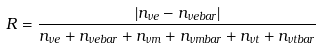Convert formula to latex. <formula><loc_0><loc_0><loc_500><loc_500>R = \frac { | n _ { \nu e } - n _ { \nu e b a r } | } { n _ { \nu e } + n _ { \nu e b a r } + n _ { \nu m } + n _ { \nu m b a r } + n _ { \nu t } + n _ { \nu t b a r } }</formula> 